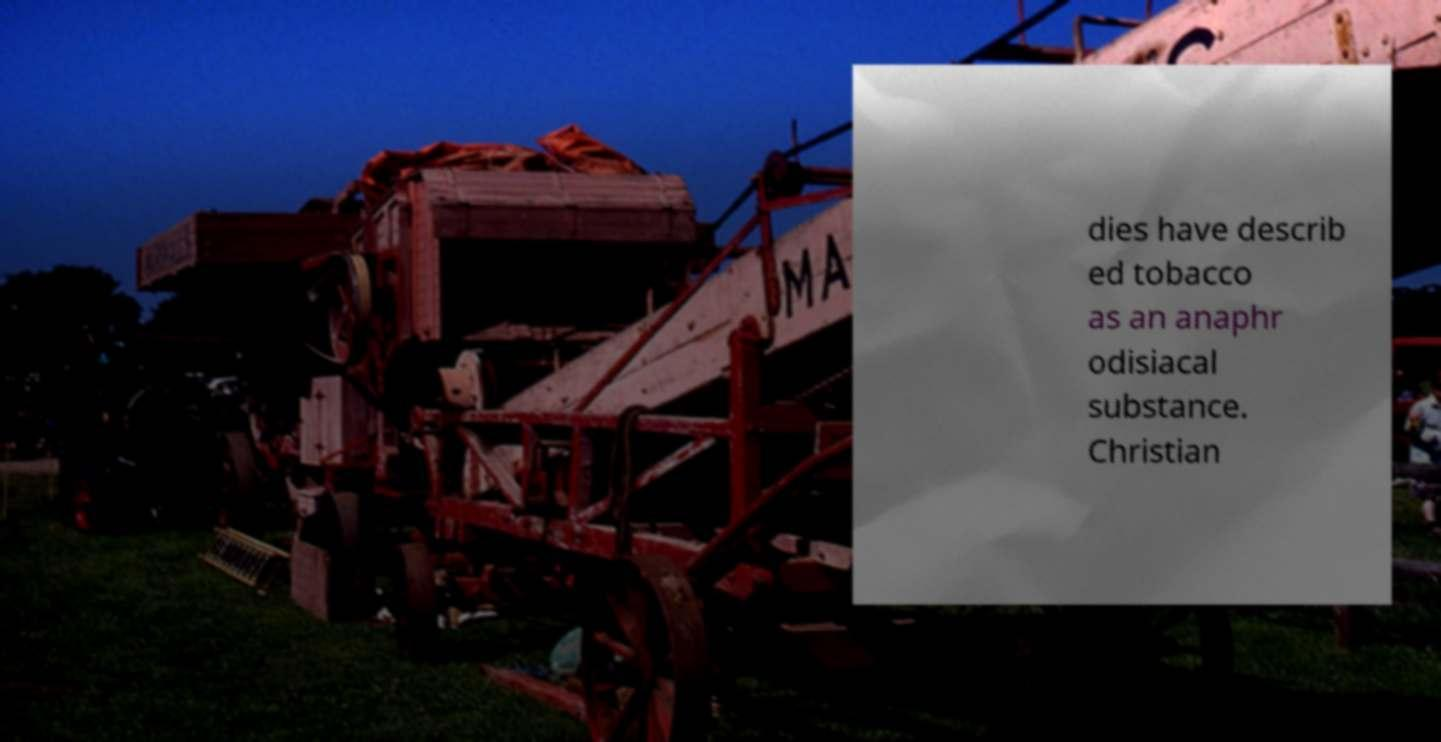What is the significance of the text juxtaposed with the image of the agricultural machine? The juxtaposition of the text describing tobacco with the image of an agricultural machine might suggest a thematic link between agriculture and tobacco cultivation, reflecting on the industrial and socio-cultural facets of tobacco production. 